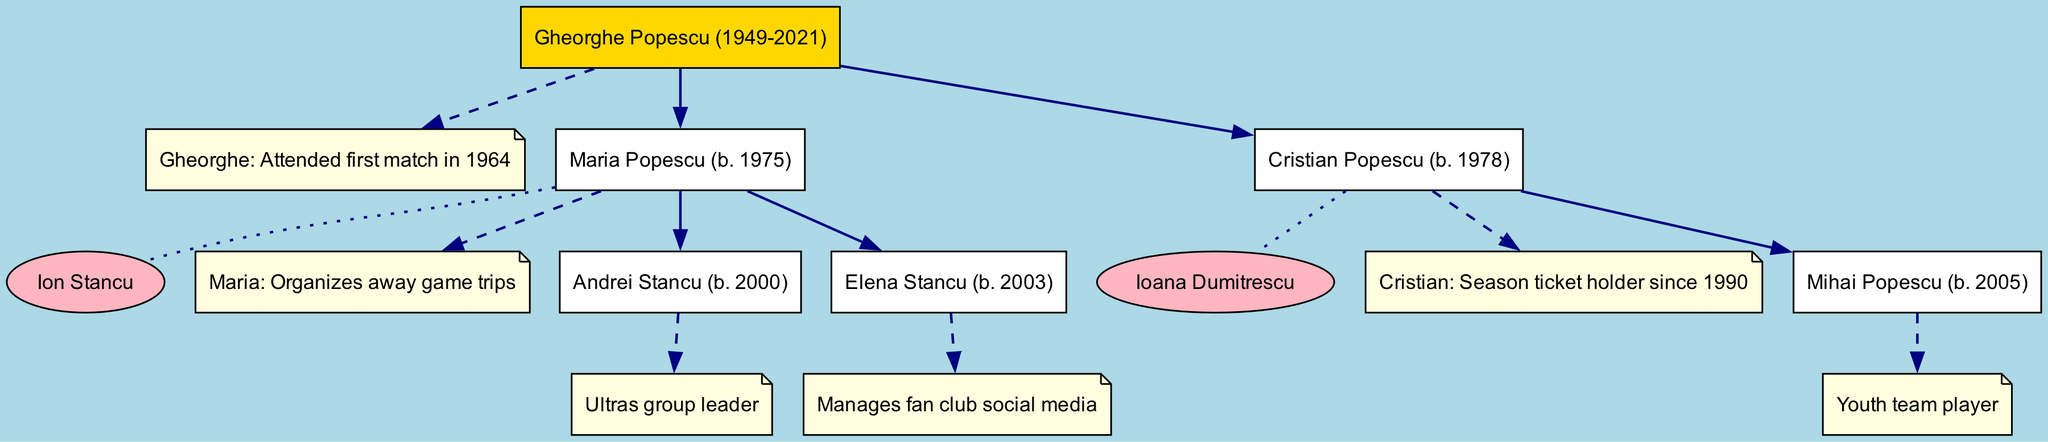What is the name of the root supporter? The root supporter is identified as "Gheorghe Popescu (1949-2021)" in the diagram.
Answer: Gheorghe Popescu (1949-2021) How many children does Gheorghe Popescu have? The diagram shows two children listed under Gheorghe Popescu: Maria Popescu and Cristian Popescu.
Answer: 2 Who is Maria Popescu's spouse? The spouse of Maria Popescu is indicated in the diagram as "Ion Stancu."
Answer: Ion Stancu Which supporter manages the fan club social media? The diagram notes that "Elena Stancu" manages the fan club's social media under her details.
Answer: Elena Stancu Which supporter has attended matches since 1990? In the diagram, it is noted that "Cristian Popescu" has been a season ticket holder since 1990.
Answer: Cristian Popescu Who is the ultras group leader? The diagram provides the note that "Andrei Stancu" holds the title of ultras group leader.
Answer: Andrei Stancu How many grandchildren does Gheorghe Popescu have? Counting the listed grandchildren, there are three: Andrei Stancu, Elena Stancu, and Mihai Popescu.
Answer: 3 What is the relationship between Cristian Popescu and Mihai Popescu? The diagram indicates that Cristian Popescu is the parent of Mihai Popescu, making them parent-child.
Answer: Parent-Child What color represents the root supporter in the diagram? The root supporter is colored gold in the diagram, as specified for his node representation.
Answer: Gold 